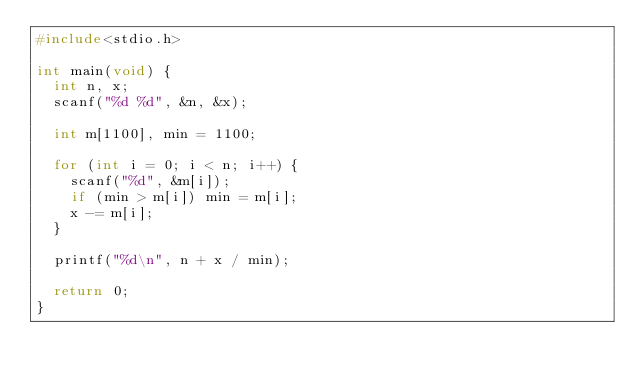<code> <loc_0><loc_0><loc_500><loc_500><_C_>#include<stdio.h>

int main(void) {
  int n, x;
  scanf("%d %d", &n, &x);

  int m[1100], min = 1100;

  for (int i = 0; i < n; i++) {
    scanf("%d", &m[i]);
    if (min > m[i]) min = m[i];
    x -= m[i];
  }

  printf("%d\n", n + x / min);

  return 0;
}
</code> 